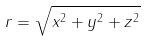Convert formula to latex. <formula><loc_0><loc_0><loc_500><loc_500>r = \sqrt { x ^ { 2 } + y ^ { 2 } + z ^ { 2 } }</formula> 